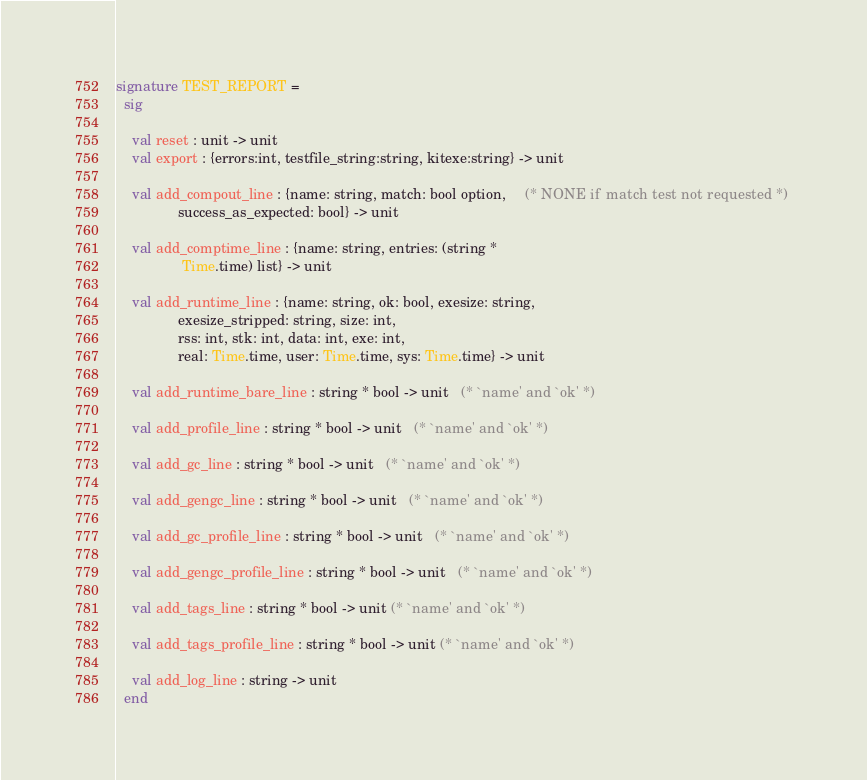Convert code to text. <code><loc_0><loc_0><loc_500><loc_500><_SML_>signature TEST_REPORT =
  sig
    
    val reset : unit -> unit
    val export : {errors:int, testfile_string:string, kitexe:string} -> unit

    val add_compout_line : {name: string, match: bool option,     (* NONE if match test not requested *) 
			    success_as_expected: bool} -> unit

    val add_comptime_line : {name: string, entries: (string *
			     Time.time) list} -> unit

    val add_runtime_line : {name: string, ok: bool, exesize: string,
			    exesize_stripped: string, size: int, 
			    rss: int, stk: int, data: int, exe: int, 
			    real: Time.time, user: Time.time, sys: Time.time} -> unit

    val add_runtime_bare_line : string * bool -> unit   (* `name' and `ok' *)

    val add_profile_line : string * bool -> unit   (* `name' and `ok' *)

    val add_gc_line : string * bool -> unit   (* `name' and `ok' *)

    val add_gengc_line : string * bool -> unit   (* `name' and `ok' *)

    val add_gc_profile_line : string * bool -> unit   (* `name' and `ok' *)

    val add_gengc_profile_line : string * bool -> unit   (* `name' and `ok' *)

    val add_tags_line : string * bool -> unit (* `name' and `ok' *)

    val add_tags_profile_line : string * bool -> unit (* `name' and `ok' *)

    val add_log_line : string -> unit
  end
</code> 